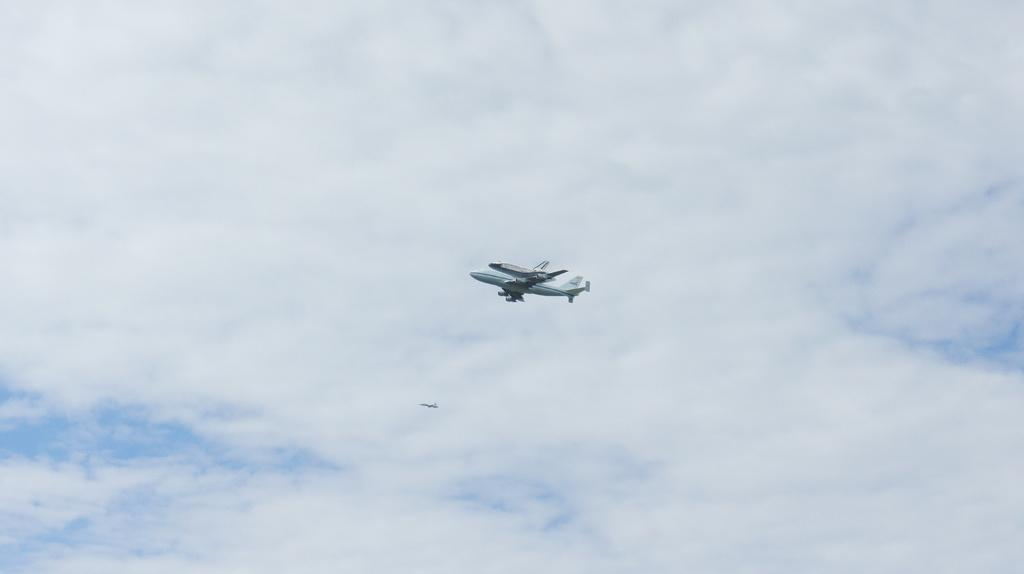What is happening in the image? There are aircrafts flying in the image. What can be seen at the top of the image? The sky is visible at the top of the image. What is present in the sky? There are clouds in the sky. Can you see a train passing by in the image? No, there is no train present in the image. Are there any jellyfish visible in the sky? No, there are no jellyfish present in the image. 